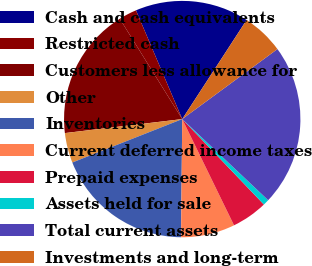Convert chart to OTSL. <chart><loc_0><loc_0><loc_500><loc_500><pie_chart><fcel>Cash and cash equivalents<fcel>Restricted cash<fcel>Customers less allowance for<fcel>Other<fcel>Inventories<fcel>Current deferred income taxes<fcel>Prepaid expenses<fcel>Assets held for sale<fcel>Total current assets<fcel>Investments and long-term<nl><fcel>15.57%<fcel>2.46%<fcel>18.03%<fcel>4.1%<fcel>18.85%<fcel>7.38%<fcel>4.92%<fcel>0.82%<fcel>22.13%<fcel>5.74%<nl></chart> 